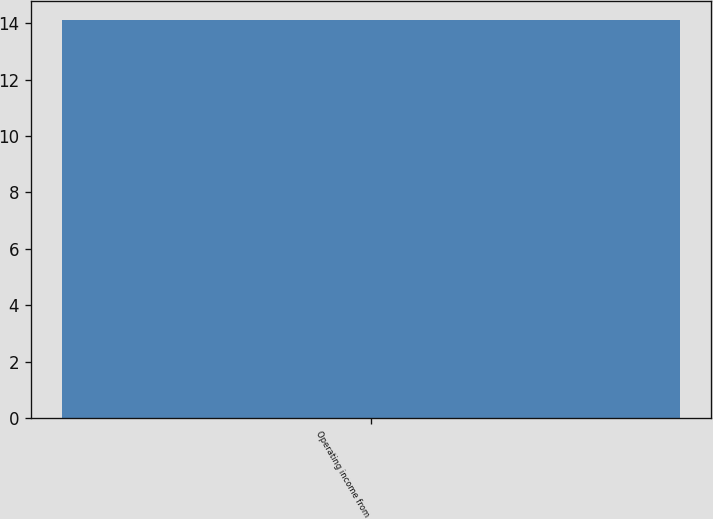Convert chart to OTSL. <chart><loc_0><loc_0><loc_500><loc_500><bar_chart><fcel>Operating income from<nl><fcel>14.1<nl></chart> 